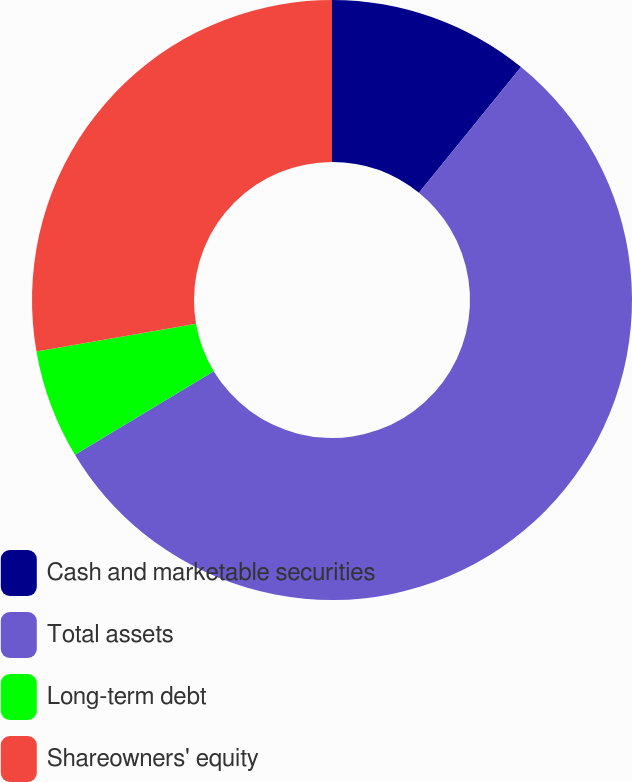Convert chart. <chart><loc_0><loc_0><loc_500><loc_500><pie_chart><fcel>Cash and marketable securities<fcel>Total assets<fcel>Long-term debt<fcel>Shareowners' equity<nl><fcel>10.85%<fcel>55.53%<fcel>5.88%<fcel>27.74%<nl></chart> 